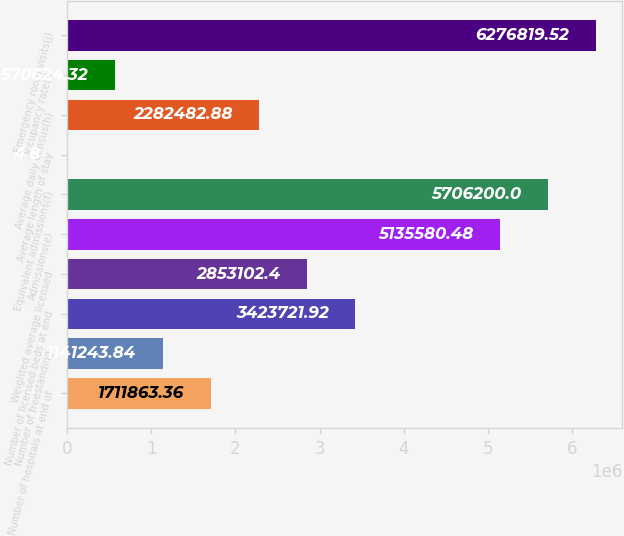<chart> <loc_0><loc_0><loc_500><loc_500><bar_chart><fcel>Number of hospitals at end of<fcel>Number of freestanding<fcel>Number of licensed beds at end<fcel>Weighted average licensed<fcel>Admissions(e)<fcel>Equivalent admissions(f)<fcel>Average length of stay<fcel>Average daily census(h)<fcel>Occupancy rate(i)<fcel>Emergency room visits(j)<nl><fcel>1.71186e+06<fcel>1.14124e+06<fcel>3.42372e+06<fcel>2.8531e+06<fcel>5.13558e+06<fcel>5.7062e+06<fcel>4.8<fcel>2.28248e+06<fcel>570624<fcel>6.27682e+06<nl></chart> 